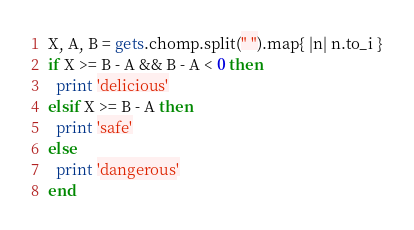<code> <loc_0><loc_0><loc_500><loc_500><_Ruby_>X, A, B = gets.chomp.split(" ").map{ |n| n.to_i }
if X >= B - A && B - A < 0 then
  print 'delicious'
elsif X >= B - A then
  print 'safe'
else
  print 'dangerous'
end
</code> 